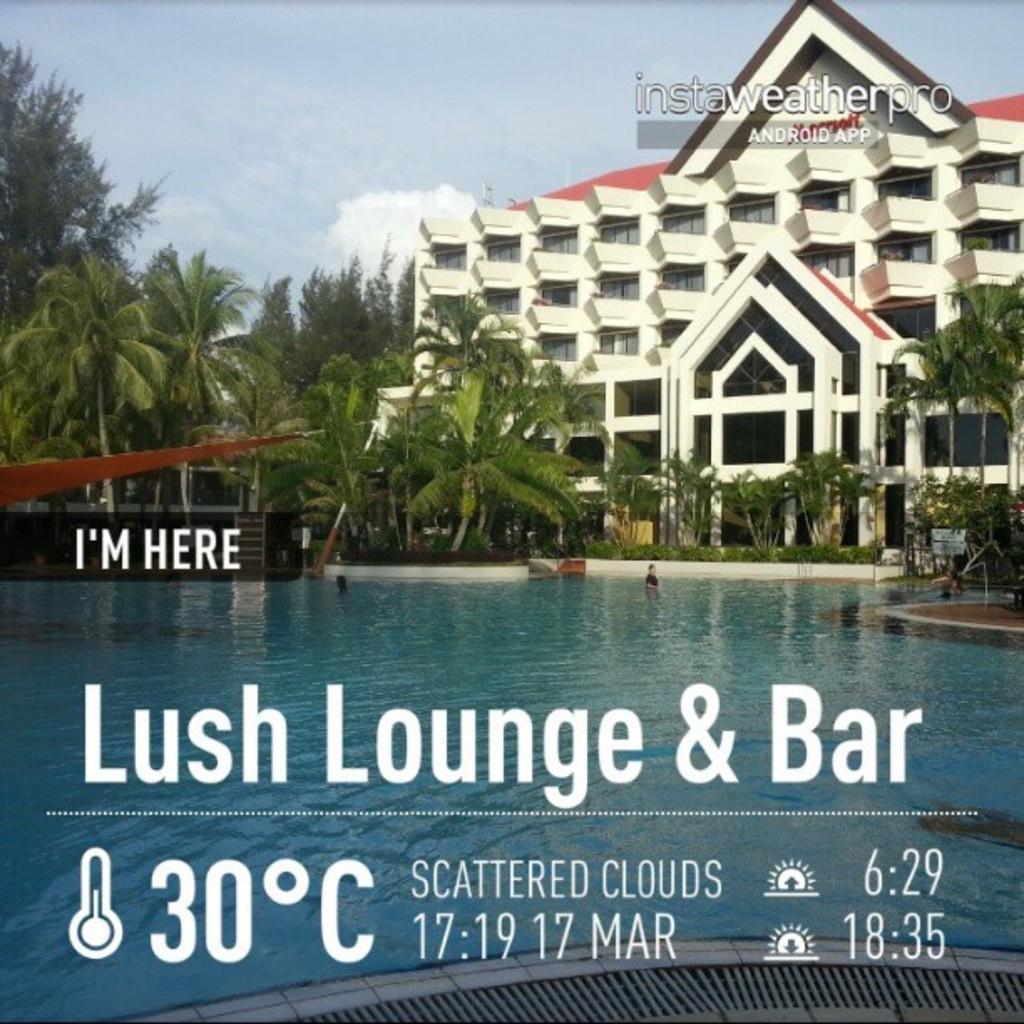How would you summarize this image in a sentence or two? There is water. In the back there are many trees and building with windows. Also there is sky with clouds. Also something is written on the image. At the bottom there is a drainage grill. 